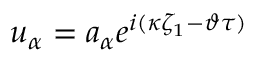Convert formula to latex. <formula><loc_0><loc_0><loc_500><loc_500>u _ { \alpha } = a _ { \alpha } e ^ { i ( \kappa \zeta _ { 1 } - \vartheta \tau ) }</formula> 